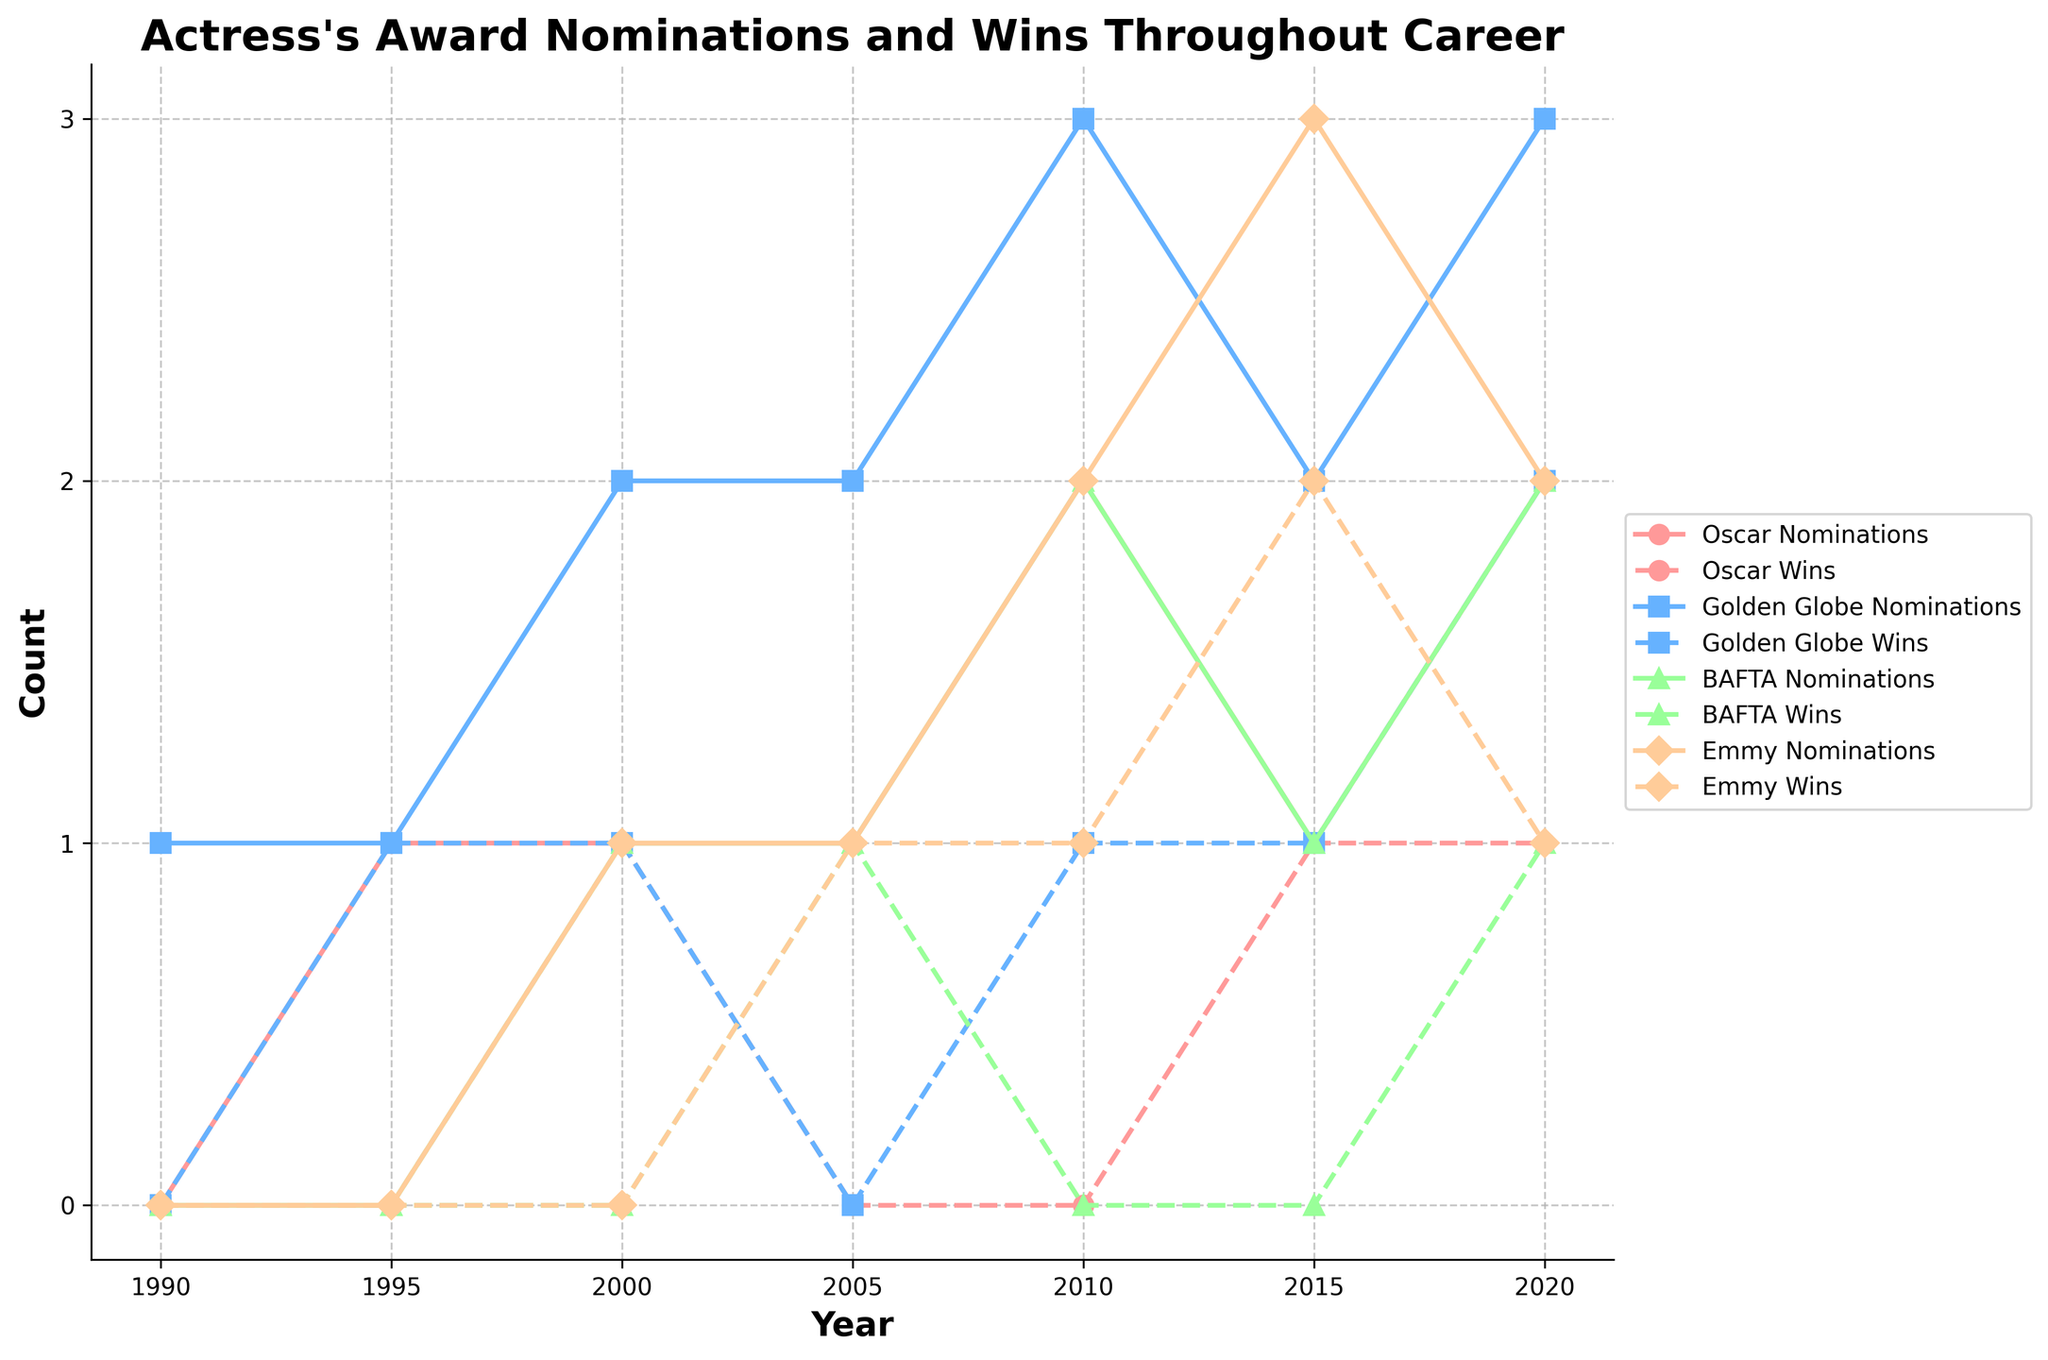What's the total number of Oscar nominations in 2010? Observe the 'Oscar Nominations' data point for the year 2010, which is positioned vertically along the 2 mark on the y-axis.
Answer: 2 How many Emmy awards did the actress win in 2015 and 2020 combined? Check the 'Emmy Wins' data points for the years 2015 and 2020, which are 2 and 1 respectively. Adding these gives 2 + 1 = 3.
Answer: 3 In which year did the actress receive her first Oscar win? Find the earliest year where the 'Oscar Wins' line intersects with a positive y-value. This occurs in 2000, where there is a single Oscar win represented by a dashed line.
Answer: 2000 Did the actress receive more Golden Globe nominations or Emmy nominations in 2010? Compare the height of the points for 'Golden Globe Nominations' and 'Emmy Nominations' for the year 2010. Golden Globe Nominations are at 3, and Emmy Nominations are at 2.
Answer: Golden Globe nominations What pattern do you observe in BAFTA nominations from 2000 to 2020? Analyze the 'BAFTA Nominations' trend from 2000 to 2020: It increases from 0 in 2000 to 1 in 2005, then to 2 in 2010, 1 in 2015, and back to 2 in 2020, showing a generally upward trend with minor fluctuation.
Answer: Upward trend with fluctuation In which year did the actress have the highest combined number of wins across all award categories? Check all the 'Wins' data points for each year and sum them:
1990: 0,
1995: 1+0=1,
2000: 1+1=2,
2005: 0+1+1=2,
2010: 1+0+1=2,
2015: 1+1+2=4,
2020: 1+2+1=4.
The years 2015 and 2020 both have the highest combined number of wins, equal to 4.
Answer: 2015 and 2020 Which category shows the most consistent number of nominations over the years? Compare the 'nominations' lines for Oscar, Golden Globe, BAFTA, and Emmy across the years in terms of how steady or fluctuating each line is. Oscar nominations are relatively consistent (0-2), whereas the others fluctuate more.
Answer: Oscar In which year were the Emmy wins numerically equal to the Oscar wins? Look for intersection points where the 'Emmy Wins' and 'Oscar Wins' dashed lines coincide at the same y-value. This occurs only in 2020, where both Emmy and Oscar wins are 1.
Answer: 2020 